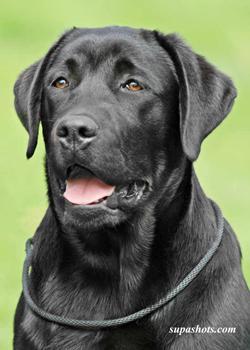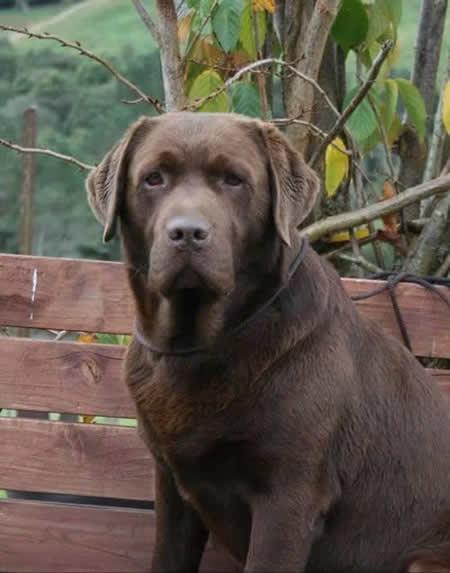The first image is the image on the left, the second image is the image on the right. Given the left and right images, does the statement "A large brown colored dog is outside." hold true? Answer yes or no. Yes. The first image is the image on the left, the second image is the image on the right. Assess this claim about the two images: "One of the images shows a black labrador and the other shows a brown labrador.". Correct or not? Answer yes or no. Yes. 